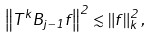<formula> <loc_0><loc_0><loc_500><loc_500>\left \| T ^ { k } B _ { j - 1 } f \right \| ^ { 2 } \lesssim \left \| f \right \| _ { k } ^ { 2 } ,</formula> 